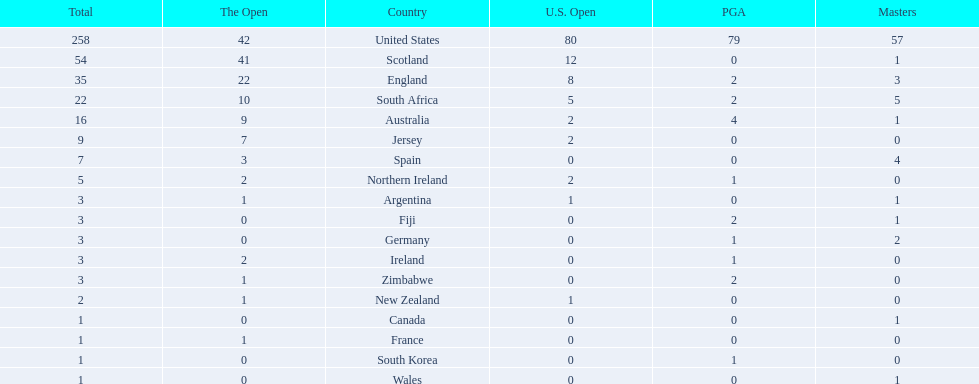Which of the countries listed are african? South Africa, Zimbabwe. Which of those has the least championship winning golfers? Zimbabwe. 